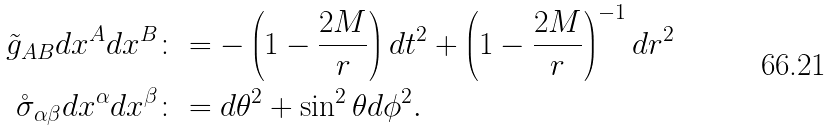<formula> <loc_0><loc_0><loc_500><loc_500>\tilde { g } _ { A B } d x ^ { A } d x ^ { B } & \colon = - \left ( 1 - \frac { 2 M } { r } \right ) d t ^ { 2 } + \left ( 1 - \frac { 2 M } { r } \right ) ^ { - 1 } d r ^ { 2 } \\ \mathring { \sigma } _ { \alpha \beta } d x ^ { \alpha } d x ^ { \beta } & \colon = d \theta ^ { 2 } + \sin ^ { 2 } \theta d \phi ^ { 2 } .</formula> 